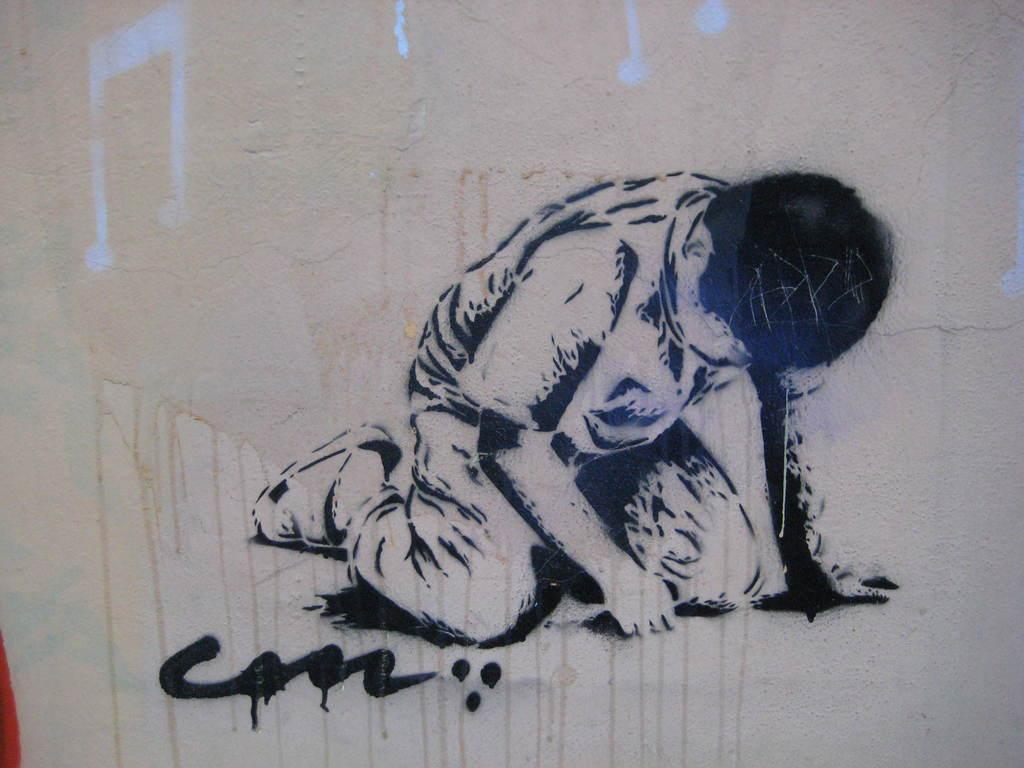What is present on the wall in the image? There is a painting of a person on the wall. Are there any other elements on the wall besides the painting? Yes, there are symbols on the wall. Can you see the doll breathing in the image? There is no doll present in the image, and therefore no breathing can be observed. Is the painting of the person on the wall able to be touched in the image? The image is two-dimensional, so it is not possible to touch the painting in the image. 